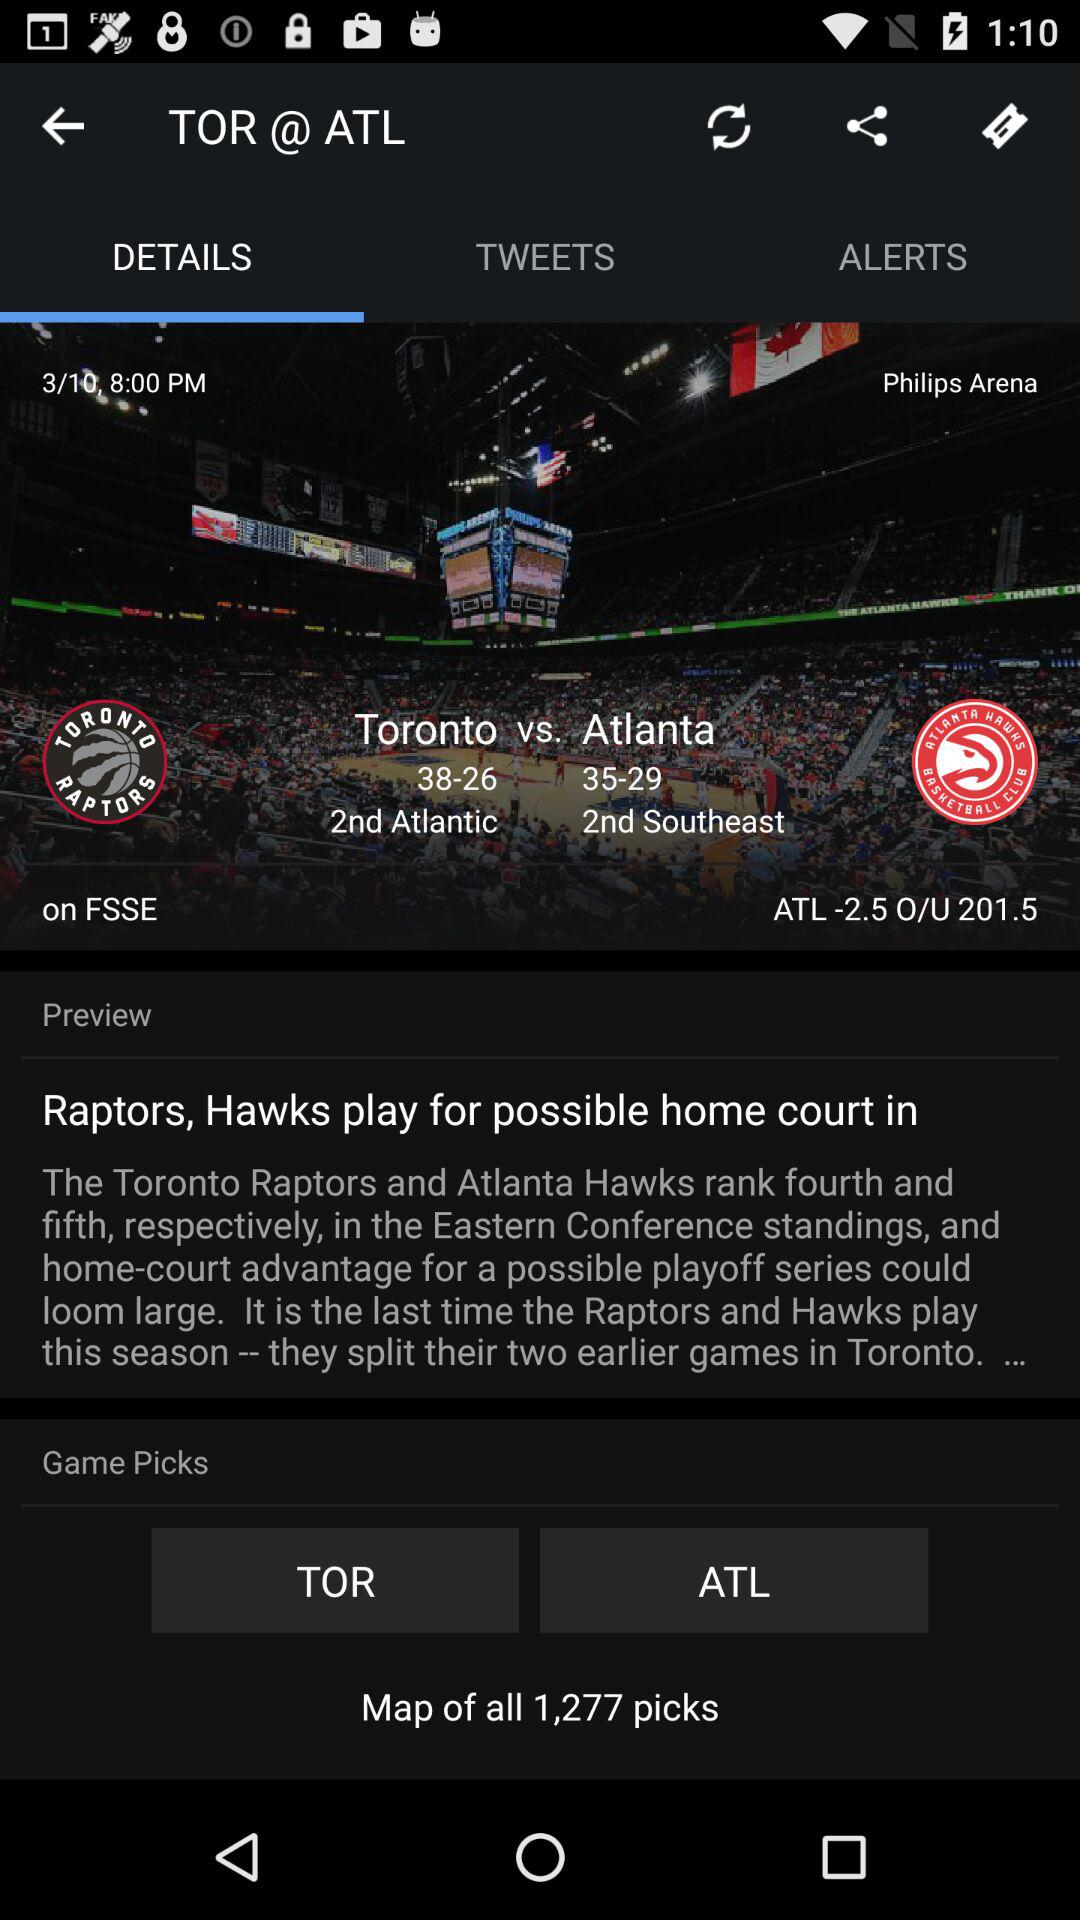What are the figures for Toronto? The figures are 38-26. 